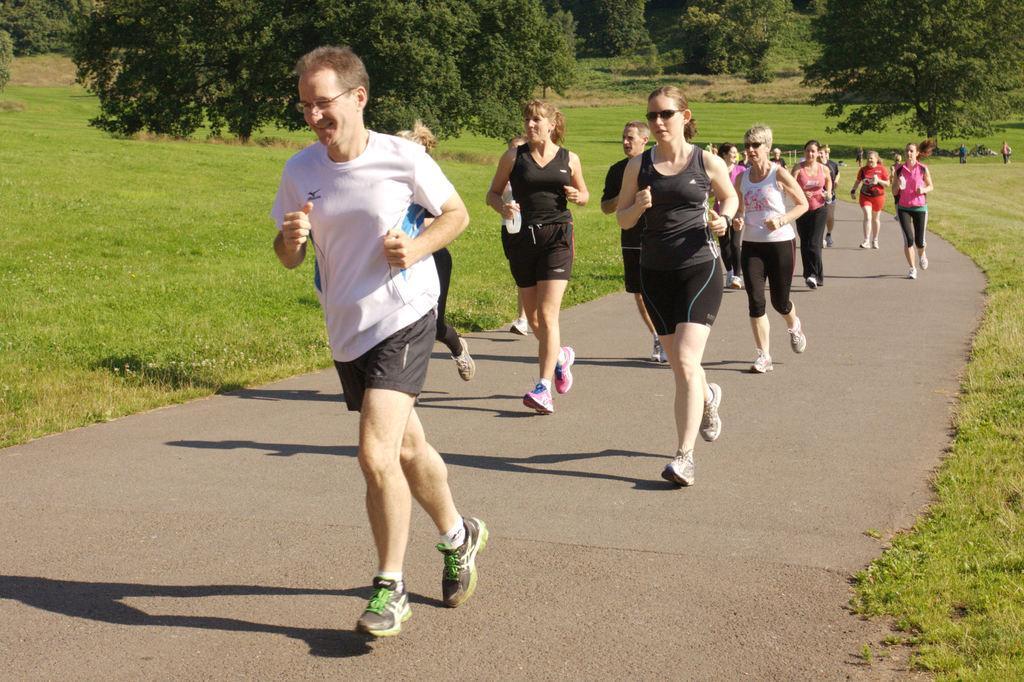In one or two sentences, can you explain what this image depicts? In this image we can see people running on the road. In the background there are trees and we can see grass. 